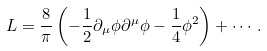<formula> <loc_0><loc_0><loc_500><loc_500>L = \frac { 8 } { \pi } \left ( - \frac { 1 } { 2 } \partial _ { \mu } \phi \partial ^ { \mu } \phi - \frac { 1 } { 4 } \phi ^ { 2 } \right ) + \cdots .</formula> 